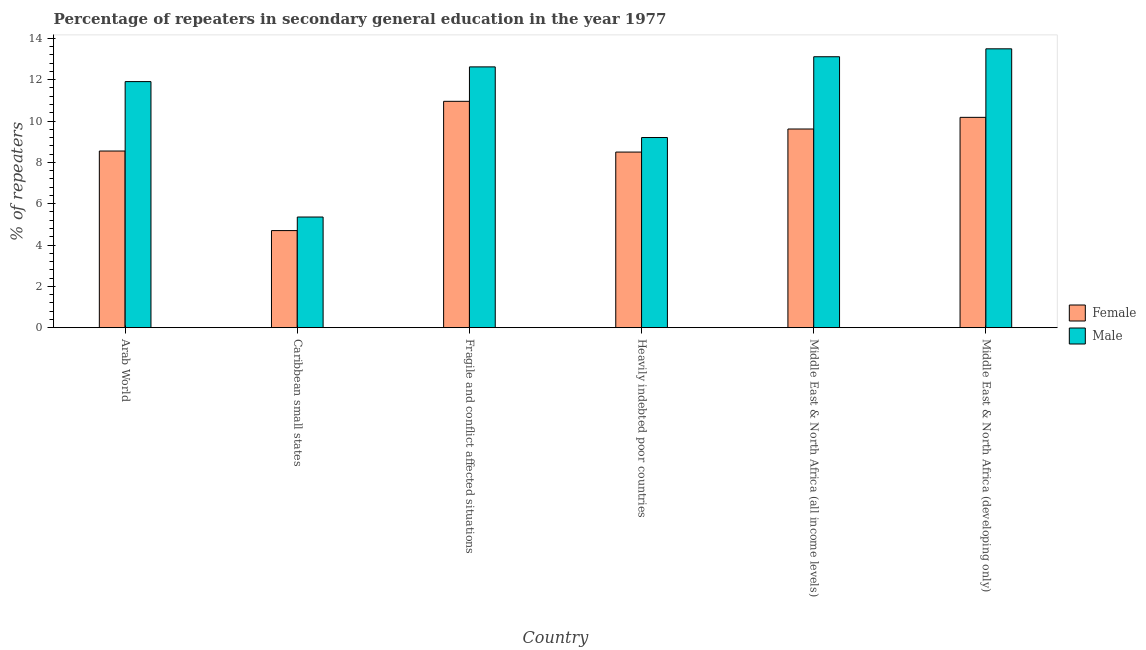How many different coloured bars are there?
Make the answer very short. 2. Are the number of bars per tick equal to the number of legend labels?
Keep it short and to the point. Yes. Are the number of bars on each tick of the X-axis equal?
Give a very brief answer. Yes. What is the label of the 3rd group of bars from the left?
Offer a very short reply. Fragile and conflict affected situations. What is the percentage of female repeaters in Caribbean small states?
Give a very brief answer. 4.7. Across all countries, what is the maximum percentage of male repeaters?
Make the answer very short. 13.5. Across all countries, what is the minimum percentage of male repeaters?
Make the answer very short. 5.35. In which country was the percentage of female repeaters maximum?
Give a very brief answer. Fragile and conflict affected situations. In which country was the percentage of female repeaters minimum?
Your answer should be compact. Caribbean small states. What is the total percentage of male repeaters in the graph?
Offer a terse response. 65.7. What is the difference between the percentage of female repeaters in Heavily indebted poor countries and that in Middle East & North Africa (developing only)?
Keep it short and to the point. -1.68. What is the difference between the percentage of female repeaters in Caribbean small states and the percentage of male repeaters in Middle East & North Africa (all income levels)?
Give a very brief answer. -8.41. What is the average percentage of female repeaters per country?
Keep it short and to the point. 8.75. What is the difference between the percentage of male repeaters and percentage of female repeaters in Arab World?
Your answer should be compact. 3.36. In how many countries, is the percentage of female repeaters greater than 2.8 %?
Give a very brief answer. 6. What is the ratio of the percentage of female repeaters in Fragile and conflict affected situations to that in Middle East & North Africa (all income levels)?
Make the answer very short. 1.14. Is the difference between the percentage of female repeaters in Caribbean small states and Fragile and conflict affected situations greater than the difference between the percentage of male repeaters in Caribbean small states and Fragile and conflict affected situations?
Provide a short and direct response. Yes. What is the difference between the highest and the second highest percentage of male repeaters?
Offer a terse response. 0.38. What is the difference between the highest and the lowest percentage of female repeaters?
Provide a succinct answer. 6.26. Is the sum of the percentage of female repeaters in Arab World and Caribbean small states greater than the maximum percentage of male repeaters across all countries?
Keep it short and to the point. No. What does the 2nd bar from the left in Fragile and conflict affected situations represents?
Ensure brevity in your answer.  Male. What does the 2nd bar from the right in Fragile and conflict affected situations represents?
Offer a terse response. Female. How many bars are there?
Your answer should be very brief. 12. Are all the bars in the graph horizontal?
Your answer should be compact. No. How are the legend labels stacked?
Provide a succinct answer. Vertical. What is the title of the graph?
Your answer should be very brief. Percentage of repeaters in secondary general education in the year 1977. What is the label or title of the Y-axis?
Your answer should be very brief. % of repeaters. What is the % of repeaters of Female in Arab World?
Provide a succinct answer. 8.55. What is the % of repeaters in Male in Arab World?
Offer a terse response. 11.91. What is the % of repeaters in Female in Caribbean small states?
Give a very brief answer. 4.7. What is the % of repeaters of Male in Caribbean small states?
Your answer should be very brief. 5.35. What is the % of repeaters in Female in Fragile and conflict affected situations?
Give a very brief answer. 10.96. What is the % of repeaters in Male in Fragile and conflict affected situations?
Provide a succinct answer. 12.62. What is the % of repeaters in Female in Heavily indebted poor countries?
Provide a short and direct response. 8.5. What is the % of repeaters of Male in Heavily indebted poor countries?
Your answer should be compact. 9.2. What is the % of repeaters in Female in Middle East & North Africa (all income levels)?
Your answer should be compact. 9.61. What is the % of repeaters in Male in Middle East & North Africa (all income levels)?
Keep it short and to the point. 13.11. What is the % of repeaters in Female in Middle East & North Africa (developing only)?
Give a very brief answer. 10.18. What is the % of repeaters in Male in Middle East & North Africa (developing only)?
Provide a succinct answer. 13.5. Across all countries, what is the maximum % of repeaters in Female?
Make the answer very short. 10.96. Across all countries, what is the maximum % of repeaters of Male?
Ensure brevity in your answer.  13.5. Across all countries, what is the minimum % of repeaters in Female?
Your response must be concise. 4.7. Across all countries, what is the minimum % of repeaters in Male?
Your response must be concise. 5.35. What is the total % of repeaters in Female in the graph?
Provide a short and direct response. 52.5. What is the total % of repeaters of Male in the graph?
Provide a short and direct response. 65.7. What is the difference between the % of repeaters of Female in Arab World and that in Caribbean small states?
Provide a succinct answer. 3.85. What is the difference between the % of repeaters in Male in Arab World and that in Caribbean small states?
Give a very brief answer. 6.55. What is the difference between the % of repeaters of Female in Arab World and that in Fragile and conflict affected situations?
Make the answer very short. -2.41. What is the difference between the % of repeaters of Male in Arab World and that in Fragile and conflict affected situations?
Give a very brief answer. -0.71. What is the difference between the % of repeaters of Female in Arab World and that in Heavily indebted poor countries?
Ensure brevity in your answer.  0.05. What is the difference between the % of repeaters in Male in Arab World and that in Heavily indebted poor countries?
Your response must be concise. 2.71. What is the difference between the % of repeaters in Female in Arab World and that in Middle East & North Africa (all income levels)?
Provide a short and direct response. -1.06. What is the difference between the % of repeaters in Male in Arab World and that in Middle East & North Africa (all income levels)?
Your answer should be compact. -1.2. What is the difference between the % of repeaters of Female in Arab World and that in Middle East & North Africa (developing only)?
Ensure brevity in your answer.  -1.63. What is the difference between the % of repeaters in Male in Arab World and that in Middle East & North Africa (developing only)?
Your response must be concise. -1.59. What is the difference between the % of repeaters in Female in Caribbean small states and that in Fragile and conflict affected situations?
Offer a terse response. -6.26. What is the difference between the % of repeaters in Male in Caribbean small states and that in Fragile and conflict affected situations?
Your answer should be very brief. -7.27. What is the difference between the % of repeaters of Female in Caribbean small states and that in Heavily indebted poor countries?
Give a very brief answer. -3.8. What is the difference between the % of repeaters in Male in Caribbean small states and that in Heavily indebted poor countries?
Your response must be concise. -3.85. What is the difference between the % of repeaters of Female in Caribbean small states and that in Middle East & North Africa (all income levels)?
Keep it short and to the point. -4.92. What is the difference between the % of repeaters of Male in Caribbean small states and that in Middle East & North Africa (all income levels)?
Give a very brief answer. -7.76. What is the difference between the % of repeaters of Female in Caribbean small states and that in Middle East & North Africa (developing only)?
Provide a short and direct response. -5.48. What is the difference between the % of repeaters of Male in Caribbean small states and that in Middle East & North Africa (developing only)?
Your response must be concise. -8.14. What is the difference between the % of repeaters of Female in Fragile and conflict affected situations and that in Heavily indebted poor countries?
Provide a succinct answer. 2.46. What is the difference between the % of repeaters of Male in Fragile and conflict affected situations and that in Heavily indebted poor countries?
Your answer should be very brief. 3.42. What is the difference between the % of repeaters in Female in Fragile and conflict affected situations and that in Middle East & North Africa (all income levels)?
Make the answer very short. 1.34. What is the difference between the % of repeaters of Male in Fragile and conflict affected situations and that in Middle East & North Africa (all income levels)?
Your answer should be compact. -0.49. What is the difference between the % of repeaters of Female in Fragile and conflict affected situations and that in Middle East & North Africa (developing only)?
Provide a short and direct response. 0.78. What is the difference between the % of repeaters of Male in Fragile and conflict affected situations and that in Middle East & North Africa (developing only)?
Give a very brief answer. -0.87. What is the difference between the % of repeaters in Female in Heavily indebted poor countries and that in Middle East & North Africa (all income levels)?
Offer a terse response. -1.12. What is the difference between the % of repeaters of Male in Heavily indebted poor countries and that in Middle East & North Africa (all income levels)?
Provide a succinct answer. -3.91. What is the difference between the % of repeaters of Female in Heavily indebted poor countries and that in Middle East & North Africa (developing only)?
Offer a very short reply. -1.68. What is the difference between the % of repeaters in Male in Heavily indebted poor countries and that in Middle East & North Africa (developing only)?
Ensure brevity in your answer.  -4.29. What is the difference between the % of repeaters in Female in Middle East & North Africa (all income levels) and that in Middle East & North Africa (developing only)?
Your response must be concise. -0.56. What is the difference between the % of repeaters of Male in Middle East & North Africa (all income levels) and that in Middle East & North Africa (developing only)?
Your response must be concise. -0.38. What is the difference between the % of repeaters in Female in Arab World and the % of repeaters in Male in Caribbean small states?
Offer a terse response. 3.19. What is the difference between the % of repeaters in Female in Arab World and the % of repeaters in Male in Fragile and conflict affected situations?
Keep it short and to the point. -4.07. What is the difference between the % of repeaters in Female in Arab World and the % of repeaters in Male in Heavily indebted poor countries?
Your answer should be compact. -0.65. What is the difference between the % of repeaters in Female in Arab World and the % of repeaters in Male in Middle East & North Africa (all income levels)?
Keep it short and to the point. -4.56. What is the difference between the % of repeaters in Female in Arab World and the % of repeaters in Male in Middle East & North Africa (developing only)?
Offer a terse response. -4.95. What is the difference between the % of repeaters in Female in Caribbean small states and the % of repeaters in Male in Fragile and conflict affected situations?
Your answer should be very brief. -7.92. What is the difference between the % of repeaters of Female in Caribbean small states and the % of repeaters of Male in Heavily indebted poor countries?
Ensure brevity in your answer.  -4.5. What is the difference between the % of repeaters of Female in Caribbean small states and the % of repeaters of Male in Middle East & North Africa (all income levels)?
Make the answer very short. -8.41. What is the difference between the % of repeaters of Female in Caribbean small states and the % of repeaters of Male in Middle East & North Africa (developing only)?
Offer a terse response. -8.8. What is the difference between the % of repeaters of Female in Fragile and conflict affected situations and the % of repeaters of Male in Heavily indebted poor countries?
Provide a succinct answer. 1.75. What is the difference between the % of repeaters in Female in Fragile and conflict affected situations and the % of repeaters in Male in Middle East & North Africa (all income levels)?
Offer a very short reply. -2.16. What is the difference between the % of repeaters of Female in Fragile and conflict affected situations and the % of repeaters of Male in Middle East & North Africa (developing only)?
Your response must be concise. -2.54. What is the difference between the % of repeaters of Female in Heavily indebted poor countries and the % of repeaters of Male in Middle East & North Africa (all income levels)?
Provide a short and direct response. -4.61. What is the difference between the % of repeaters in Female in Heavily indebted poor countries and the % of repeaters in Male in Middle East & North Africa (developing only)?
Your response must be concise. -5. What is the difference between the % of repeaters in Female in Middle East & North Africa (all income levels) and the % of repeaters in Male in Middle East & North Africa (developing only)?
Offer a very short reply. -3.88. What is the average % of repeaters of Female per country?
Ensure brevity in your answer.  8.75. What is the average % of repeaters of Male per country?
Provide a succinct answer. 10.95. What is the difference between the % of repeaters of Female and % of repeaters of Male in Arab World?
Keep it short and to the point. -3.36. What is the difference between the % of repeaters in Female and % of repeaters in Male in Caribbean small states?
Offer a terse response. -0.66. What is the difference between the % of repeaters of Female and % of repeaters of Male in Fragile and conflict affected situations?
Offer a very short reply. -1.67. What is the difference between the % of repeaters of Female and % of repeaters of Male in Heavily indebted poor countries?
Provide a short and direct response. -0.7. What is the difference between the % of repeaters in Female and % of repeaters in Male in Middle East & North Africa (all income levels)?
Your answer should be very brief. -3.5. What is the difference between the % of repeaters in Female and % of repeaters in Male in Middle East & North Africa (developing only)?
Your answer should be compact. -3.32. What is the ratio of the % of repeaters in Female in Arab World to that in Caribbean small states?
Offer a terse response. 1.82. What is the ratio of the % of repeaters of Male in Arab World to that in Caribbean small states?
Provide a short and direct response. 2.22. What is the ratio of the % of repeaters of Female in Arab World to that in Fragile and conflict affected situations?
Offer a very short reply. 0.78. What is the ratio of the % of repeaters of Male in Arab World to that in Fragile and conflict affected situations?
Your response must be concise. 0.94. What is the ratio of the % of repeaters in Female in Arab World to that in Heavily indebted poor countries?
Make the answer very short. 1.01. What is the ratio of the % of repeaters of Male in Arab World to that in Heavily indebted poor countries?
Your answer should be very brief. 1.29. What is the ratio of the % of repeaters in Female in Arab World to that in Middle East & North Africa (all income levels)?
Offer a very short reply. 0.89. What is the ratio of the % of repeaters of Male in Arab World to that in Middle East & North Africa (all income levels)?
Make the answer very short. 0.91. What is the ratio of the % of repeaters of Female in Arab World to that in Middle East & North Africa (developing only)?
Provide a succinct answer. 0.84. What is the ratio of the % of repeaters of Male in Arab World to that in Middle East & North Africa (developing only)?
Your answer should be very brief. 0.88. What is the ratio of the % of repeaters in Female in Caribbean small states to that in Fragile and conflict affected situations?
Your response must be concise. 0.43. What is the ratio of the % of repeaters of Male in Caribbean small states to that in Fragile and conflict affected situations?
Your answer should be very brief. 0.42. What is the ratio of the % of repeaters in Female in Caribbean small states to that in Heavily indebted poor countries?
Your answer should be compact. 0.55. What is the ratio of the % of repeaters of Male in Caribbean small states to that in Heavily indebted poor countries?
Offer a very short reply. 0.58. What is the ratio of the % of repeaters in Female in Caribbean small states to that in Middle East & North Africa (all income levels)?
Provide a succinct answer. 0.49. What is the ratio of the % of repeaters in Male in Caribbean small states to that in Middle East & North Africa (all income levels)?
Your answer should be very brief. 0.41. What is the ratio of the % of repeaters of Female in Caribbean small states to that in Middle East & North Africa (developing only)?
Ensure brevity in your answer.  0.46. What is the ratio of the % of repeaters of Male in Caribbean small states to that in Middle East & North Africa (developing only)?
Keep it short and to the point. 0.4. What is the ratio of the % of repeaters of Female in Fragile and conflict affected situations to that in Heavily indebted poor countries?
Offer a terse response. 1.29. What is the ratio of the % of repeaters of Male in Fragile and conflict affected situations to that in Heavily indebted poor countries?
Ensure brevity in your answer.  1.37. What is the ratio of the % of repeaters in Female in Fragile and conflict affected situations to that in Middle East & North Africa (all income levels)?
Ensure brevity in your answer.  1.14. What is the ratio of the % of repeaters of Male in Fragile and conflict affected situations to that in Middle East & North Africa (all income levels)?
Your answer should be compact. 0.96. What is the ratio of the % of repeaters in Female in Fragile and conflict affected situations to that in Middle East & North Africa (developing only)?
Provide a succinct answer. 1.08. What is the ratio of the % of repeaters of Male in Fragile and conflict affected situations to that in Middle East & North Africa (developing only)?
Ensure brevity in your answer.  0.94. What is the ratio of the % of repeaters of Female in Heavily indebted poor countries to that in Middle East & North Africa (all income levels)?
Your answer should be compact. 0.88. What is the ratio of the % of repeaters of Male in Heavily indebted poor countries to that in Middle East & North Africa (all income levels)?
Offer a terse response. 0.7. What is the ratio of the % of repeaters in Female in Heavily indebted poor countries to that in Middle East & North Africa (developing only)?
Give a very brief answer. 0.83. What is the ratio of the % of repeaters in Male in Heavily indebted poor countries to that in Middle East & North Africa (developing only)?
Your answer should be compact. 0.68. What is the ratio of the % of repeaters of Female in Middle East & North Africa (all income levels) to that in Middle East & North Africa (developing only)?
Keep it short and to the point. 0.94. What is the ratio of the % of repeaters of Male in Middle East & North Africa (all income levels) to that in Middle East & North Africa (developing only)?
Offer a terse response. 0.97. What is the difference between the highest and the second highest % of repeaters of Female?
Your answer should be very brief. 0.78. What is the difference between the highest and the second highest % of repeaters of Male?
Provide a succinct answer. 0.38. What is the difference between the highest and the lowest % of repeaters in Female?
Offer a very short reply. 6.26. What is the difference between the highest and the lowest % of repeaters in Male?
Provide a succinct answer. 8.14. 